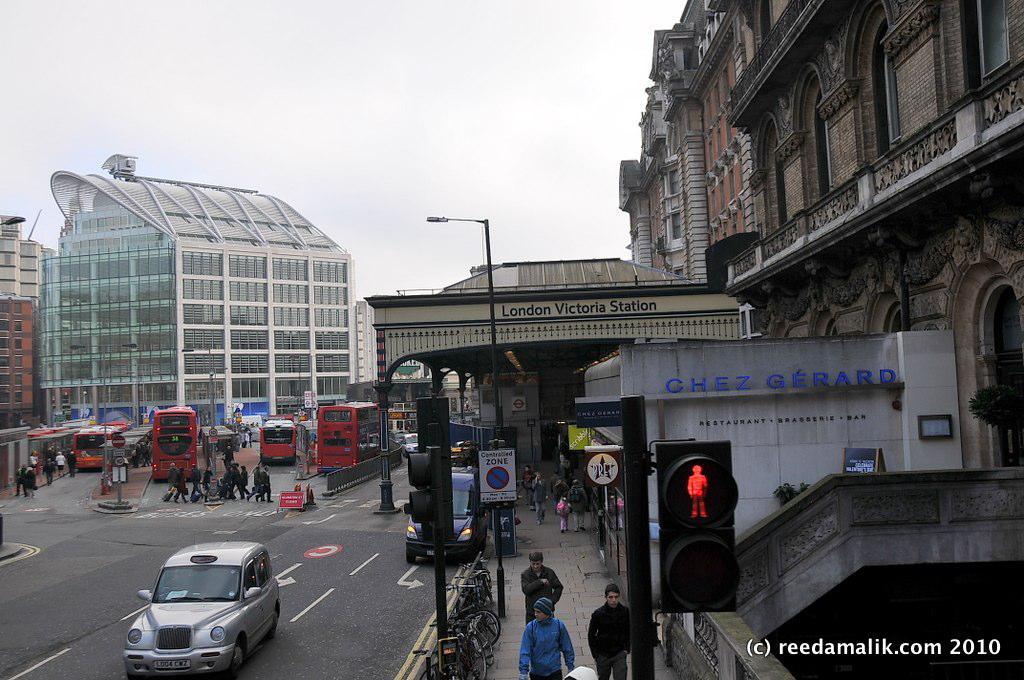What website is listed in the corner?
Your answer should be very brief. Reedamalik.com. What is the name of the station?
Your answer should be very brief. London victoria station. 